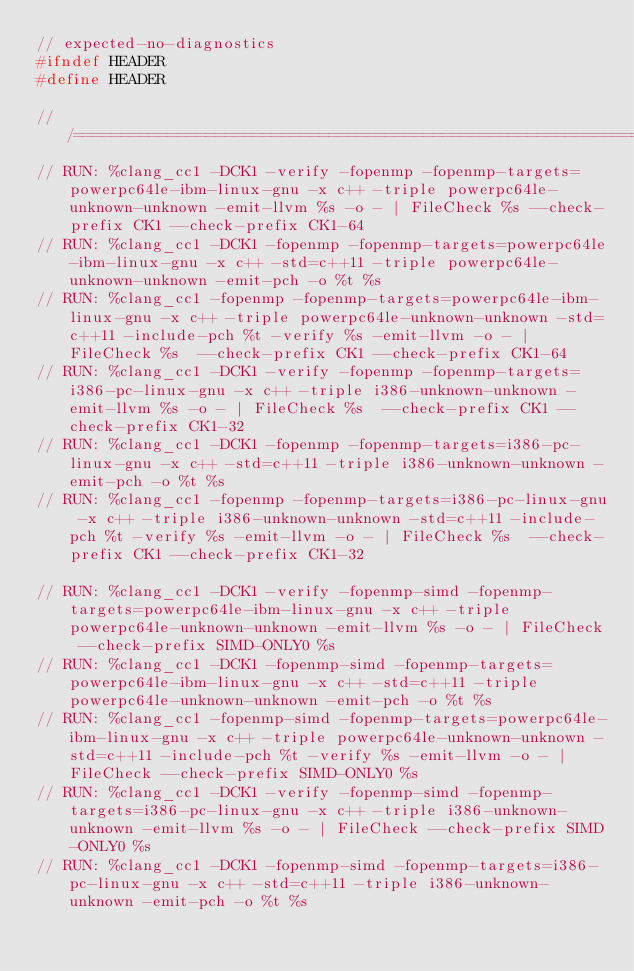<code> <loc_0><loc_0><loc_500><loc_500><_C++_>// expected-no-diagnostics
#ifndef HEADER
#define HEADER

///==========================================================================///
// RUN: %clang_cc1 -DCK1 -verify -fopenmp -fopenmp-targets=powerpc64le-ibm-linux-gnu -x c++ -triple powerpc64le-unknown-unknown -emit-llvm %s -o - | FileCheck %s --check-prefix CK1 --check-prefix CK1-64
// RUN: %clang_cc1 -DCK1 -fopenmp -fopenmp-targets=powerpc64le-ibm-linux-gnu -x c++ -std=c++11 -triple powerpc64le-unknown-unknown -emit-pch -o %t %s
// RUN: %clang_cc1 -fopenmp -fopenmp-targets=powerpc64le-ibm-linux-gnu -x c++ -triple powerpc64le-unknown-unknown -std=c++11 -include-pch %t -verify %s -emit-llvm -o - | FileCheck %s  --check-prefix CK1 --check-prefix CK1-64
// RUN: %clang_cc1 -DCK1 -verify -fopenmp -fopenmp-targets=i386-pc-linux-gnu -x c++ -triple i386-unknown-unknown -emit-llvm %s -o - | FileCheck %s  --check-prefix CK1 --check-prefix CK1-32
// RUN: %clang_cc1 -DCK1 -fopenmp -fopenmp-targets=i386-pc-linux-gnu -x c++ -std=c++11 -triple i386-unknown-unknown -emit-pch -o %t %s
// RUN: %clang_cc1 -fopenmp -fopenmp-targets=i386-pc-linux-gnu -x c++ -triple i386-unknown-unknown -std=c++11 -include-pch %t -verify %s -emit-llvm -o - | FileCheck %s  --check-prefix CK1 --check-prefix CK1-32

// RUN: %clang_cc1 -DCK1 -verify -fopenmp-simd -fopenmp-targets=powerpc64le-ibm-linux-gnu -x c++ -triple powerpc64le-unknown-unknown -emit-llvm %s -o - | FileCheck --check-prefix SIMD-ONLY0 %s
// RUN: %clang_cc1 -DCK1 -fopenmp-simd -fopenmp-targets=powerpc64le-ibm-linux-gnu -x c++ -std=c++11 -triple powerpc64le-unknown-unknown -emit-pch -o %t %s
// RUN: %clang_cc1 -fopenmp-simd -fopenmp-targets=powerpc64le-ibm-linux-gnu -x c++ -triple powerpc64le-unknown-unknown -std=c++11 -include-pch %t -verify %s -emit-llvm -o - | FileCheck --check-prefix SIMD-ONLY0 %s
// RUN: %clang_cc1 -DCK1 -verify -fopenmp-simd -fopenmp-targets=i386-pc-linux-gnu -x c++ -triple i386-unknown-unknown -emit-llvm %s -o - | FileCheck --check-prefix SIMD-ONLY0 %s
// RUN: %clang_cc1 -DCK1 -fopenmp-simd -fopenmp-targets=i386-pc-linux-gnu -x c++ -std=c++11 -triple i386-unknown-unknown -emit-pch -o %t %s</code> 